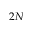Convert formula to latex. <formula><loc_0><loc_0><loc_500><loc_500>2 N</formula> 